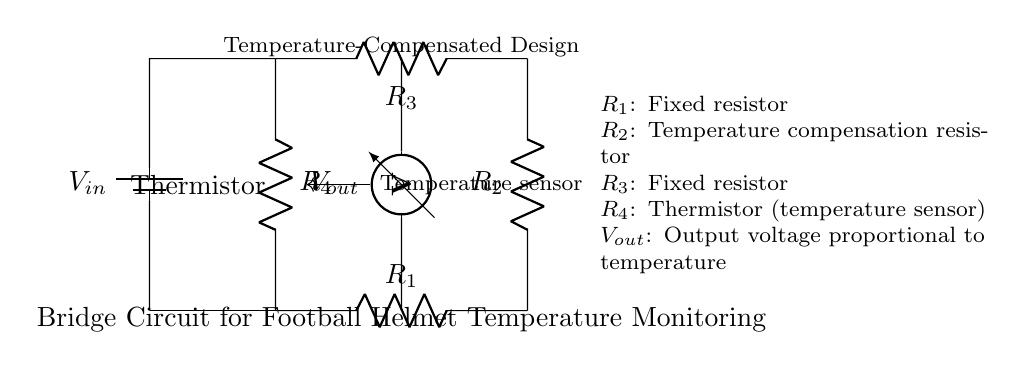What is the type of circuit depicted? The circuit shown is a bridge circuit, which features a closed-loop configuration with resistors arranged in a diamond shape, commonly used for measuring small changes in resistance.
Answer: Bridge circuit What is the function of the thermistor in this circuit? The thermistor serves as a temperature sensor; its resistance changes with temperature, allowing the circuit to monitor and measure temperature variations inside the football helmet.
Answer: Temperature sensor What is the role of resistor R2? Resistor R2 serves as a temperature compensation resistor; it helps to balance the bridge against the thermal effects that may affect the output voltage due to changes in temperature.
Answer: Temperature compensation What does the output voltage represent? The output voltage, denoted as Vout, is proportional to the resistance change caused by the thermistor, which in turn reflects the changing temperature, providing a measurable voltage output for monitoring.
Answer: Proportional to temperature What would happen if R4 (the thermistor) is replaced with a regular resistor? Replacing R4 with a regular resistor would eliminate the temperature sensitivity of the circuit, as the output would no longer vary with temperature changes, making it ineffective for monitoring temperature.
Answer: Lose temperature sensitivity How many resistors are present in this bridge circuit? There are four resistors in this bridge circuit, labeled R1, R2, R3, and R4, each serving distinct roles in determining the circuit's properties and behavior.
Answer: Four resistors 